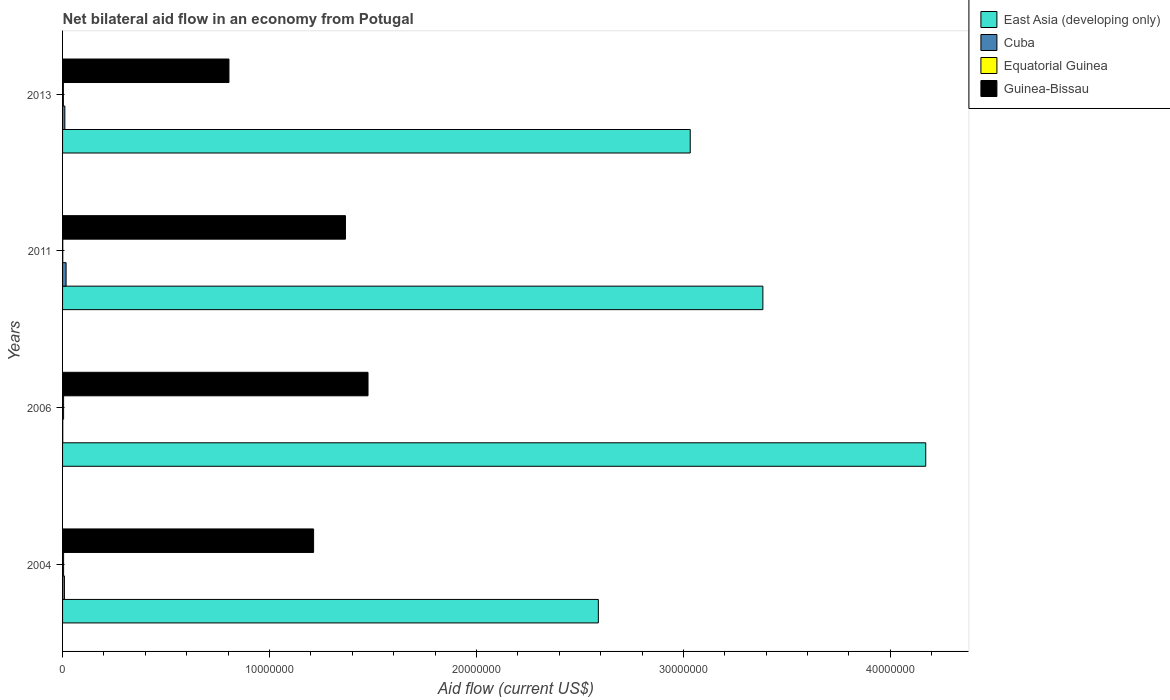How many groups of bars are there?
Offer a very short reply. 4. Are the number of bars on each tick of the Y-axis equal?
Give a very brief answer. Yes. How many bars are there on the 3rd tick from the top?
Your answer should be compact. 4. How many bars are there on the 4th tick from the bottom?
Your response must be concise. 4. What is the label of the 2nd group of bars from the top?
Keep it short and to the point. 2011. In how many cases, is the number of bars for a given year not equal to the number of legend labels?
Your answer should be very brief. 0. What is the net bilateral aid flow in Guinea-Bissau in 2013?
Provide a short and direct response. 8.04e+06. Across all years, what is the maximum net bilateral aid flow in Equatorial Guinea?
Provide a succinct answer. 5.00e+04. Across all years, what is the minimum net bilateral aid flow in Guinea-Bissau?
Your answer should be compact. 8.04e+06. In which year was the net bilateral aid flow in East Asia (developing only) maximum?
Provide a succinct answer. 2006. In which year was the net bilateral aid flow in Cuba minimum?
Give a very brief answer. 2006. What is the total net bilateral aid flow in Guinea-Bissau in the graph?
Make the answer very short. 4.86e+07. What is the difference between the net bilateral aid flow in Cuba in 2011 and that in 2013?
Provide a succinct answer. 6.00e+04. What is the difference between the net bilateral aid flow in Cuba in 2004 and the net bilateral aid flow in Equatorial Guinea in 2013?
Provide a short and direct response. 5.00e+04. What is the average net bilateral aid flow in Guinea-Bissau per year?
Offer a terse response. 1.22e+07. In the year 2006, what is the difference between the net bilateral aid flow in Cuba and net bilateral aid flow in Guinea-Bissau?
Give a very brief answer. -1.48e+07. In how many years, is the net bilateral aid flow in Guinea-Bissau greater than 8000000 US$?
Make the answer very short. 4. What is the ratio of the net bilateral aid flow in Cuba in 2006 to that in 2011?
Your answer should be compact. 0.06. Is the net bilateral aid flow in Cuba in 2004 less than that in 2011?
Provide a succinct answer. Yes. Is the difference between the net bilateral aid flow in Cuba in 2004 and 2011 greater than the difference between the net bilateral aid flow in Guinea-Bissau in 2004 and 2011?
Provide a short and direct response. Yes. What is the difference between the highest and the second highest net bilateral aid flow in Equatorial Guinea?
Ensure brevity in your answer.  0. What is the difference between the highest and the lowest net bilateral aid flow in Cuba?
Keep it short and to the point. 1.60e+05. In how many years, is the net bilateral aid flow in Equatorial Guinea greater than the average net bilateral aid flow in Equatorial Guinea taken over all years?
Your response must be concise. 3. Is it the case that in every year, the sum of the net bilateral aid flow in Equatorial Guinea and net bilateral aid flow in Guinea-Bissau is greater than the sum of net bilateral aid flow in Cuba and net bilateral aid flow in East Asia (developing only)?
Your answer should be compact. No. What does the 3rd bar from the top in 2006 represents?
Make the answer very short. Cuba. What does the 3rd bar from the bottom in 2013 represents?
Provide a short and direct response. Equatorial Guinea. What is the difference between two consecutive major ticks on the X-axis?
Ensure brevity in your answer.  1.00e+07. Does the graph contain grids?
Your response must be concise. No. How are the legend labels stacked?
Your answer should be compact. Vertical. What is the title of the graph?
Your answer should be compact. Net bilateral aid flow in an economy from Potugal. Does "Liechtenstein" appear as one of the legend labels in the graph?
Keep it short and to the point. No. What is the label or title of the X-axis?
Your answer should be compact. Aid flow (current US$). What is the label or title of the Y-axis?
Make the answer very short. Years. What is the Aid flow (current US$) of East Asia (developing only) in 2004?
Provide a succinct answer. 2.59e+07. What is the Aid flow (current US$) of Cuba in 2004?
Offer a terse response. 9.00e+04. What is the Aid flow (current US$) of Guinea-Bissau in 2004?
Your answer should be compact. 1.21e+07. What is the Aid flow (current US$) in East Asia (developing only) in 2006?
Provide a succinct answer. 4.17e+07. What is the Aid flow (current US$) in Cuba in 2006?
Make the answer very short. 10000. What is the Aid flow (current US$) of Guinea-Bissau in 2006?
Your answer should be very brief. 1.48e+07. What is the Aid flow (current US$) in East Asia (developing only) in 2011?
Make the answer very short. 3.38e+07. What is the Aid flow (current US$) of Equatorial Guinea in 2011?
Make the answer very short. 10000. What is the Aid flow (current US$) of Guinea-Bissau in 2011?
Ensure brevity in your answer.  1.37e+07. What is the Aid flow (current US$) of East Asia (developing only) in 2013?
Offer a terse response. 3.03e+07. What is the Aid flow (current US$) of Cuba in 2013?
Your response must be concise. 1.10e+05. What is the Aid flow (current US$) in Guinea-Bissau in 2013?
Provide a short and direct response. 8.04e+06. Across all years, what is the maximum Aid flow (current US$) of East Asia (developing only)?
Make the answer very short. 4.17e+07. Across all years, what is the maximum Aid flow (current US$) of Equatorial Guinea?
Your response must be concise. 5.00e+04. Across all years, what is the maximum Aid flow (current US$) of Guinea-Bissau?
Provide a short and direct response. 1.48e+07. Across all years, what is the minimum Aid flow (current US$) of East Asia (developing only)?
Provide a short and direct response. 2.59e+07. Across all years, what is the minimum Aid flow (current US$) of Equatorial Guinea?
Provide a short and direct response. 10000. Across all years, what is the minimum Aid flow (current US$) of Guinea-Bissau?
Your response must be concise. 8.04e+06. What is the total Aid flow (current US$) in East Asia (developing only) in the graph?
Make the answer very short. 1.32e+08. What is the total Aid flow (current US$) in Cuba in the graph?
Offer a very short reply. 3.80e+05. What is the total Aid flow (current US$) of Guinea-Bissau in the graph?
Keep it short and to the point. 4.86e+07. What is the difference between the Aid flow (current US$) in East Asia (developing only) in 2004 and that in 2006?
Give a very brief answer. -1.58e+07. What is the difference between the Aid flow (current US$) of Equatorial Guinea in 2004 and that in 2006?
Give a very brief answer. 0. What is the difference between the Aid flow (current US$) in Guinea-Bissau in 2004 and that in 2006?
Offer a very short reply. -2.63e+06. What is the difference between the Aid flow (current US$) of East Asia (developing only) in 2004 and that in 2011?
Give a very brief answer. -7.95e+06. What is the difference between the Aid flow (current US$) in Cuba in 2004 and that in 2011?
Give a very brief answer. -8.00e+04. What is the difference between the Aid flow (current US$) in Guinea-Bissau in 2004 and that in 2011?
Offer a very short reply. -1.54e+06. What is the difference between the Aid flow (current US$) in East Asia (developing only) in 2004 and that in 2013?
Ensure brevity in your answer.  -4.44e+06. What is the difference between the Aid flow (current US$) of Equatorial Guinea in 2004 and that in 2013?
Make the answer very short. 10000. What is the difference between the Aid flow (current US$) in Guinea-Bissau in 2004 and that in 2013?
Offer a very short reply. 4.09e+06. What is the difference between the Aid flow (current US$) of East Asia (developing only) in 2006 and that in 2011?
Provide a short and direct response. 7.87e+06. What is the difference between the Aid flow (current US$) in Equatorial Guinea in 2006 and that in 2011?
Make the answer very short. 4.00e+04. What is the difference between the Aid flow (current US$) in Guinea-Bissau in 2006 and that in 2011?
Ensure brevity in your answer.  1.09e+06. What is the difference between the Aid flow (current US$) of East Asia (developing only) in 2006 and that in 2013?
Give a very brief answer. 1.14e+07. What is the difference between the Aid flow (current US$) in Equatorial Guinea in 2006 and that in 2013?
Provide a succinct answer. 10000. What is the difference between the Aid flow (current US$) in Guinea-Bissau in 2006 and that in 2013?
Provide a succinct answer. 6.72e+06. What is the difference between the Aid flow (current US$) in East Asia (developing only) in 2011 and that in 2013?
Provide a short and direct response. 3.51e+06. What is the difference between the Aid flow (current US$) of Cuba in 2011 and that in 2013?
Your answer should be very brief. 6.00e+04. What is the difference between the Aid flow (current US$) in Equatorial Guinea in 2011 and that in 2013?
Offer a terse response. -3.00e+04. What is the difference between the Aid flow (current US$) in Guinea-Bissau in 2011 and that in 2013?
Keep it short and to the point. 5.63e+06. What is the difference between the Aid flow (current US$) of East Asia (developing only) in 2004 and the Aid flow (current US$) of Cuba in 2006?
Your answer should be compact. 2.59e+07. What is the difference between the Aid flow (current US$) of East Asia (developing only) in 2004 and the Aid flow (current US$) of Equatorial Guinea in 2006?
Provide a succinct answer. 2.58e+07. What is the difference between the Aid flow (current US$) in East Asia (developing only) in 2004 and the Aid flow (current US$) in Guinea-Bissau in 2006?
Your answer should be very brief. 1.11e+07. What is the difference between the Aid flow (current US$) of Cuba in 2004 and the Aid flow (current US$) of Equatorial Guinea in 2006?
Ensure brevity in your answer.  4.00e+04. What is the difference between the Aid flow (current US$) in Cuba in 2004 and the Aid flow (current US$) in Guinea-Bissau in 2006?
Your response must be concise. -1.47e+07. What is the difference between the Aid flow (current US$) of Equatorial Guinea in 2004 and the Aid flow (current US$) of Guinea-Bissau in 2006?
Ensure brevity in your answer.  -1.47e+07. What is the difference between the Aid flow (current US$) of East Asia (developing only) in 2004 and the Aid flow (current US$) of Cuba in 2011?
Offer a terse response. 2.57e+07. What is the difference between the Aid flow (current US$) in East Asia (developing only) in 2004 and the Aid flow (current US$) in Equatorial Guinea in 2011?
Your answer should be very brief. 2.59e+07. What is the difference between the Aid flow (current US$) in East Asia (developing only) in 2004 and the Aid flow (current US$) in Guinea-Bissau in 2011?
Provide a short and direct response. 1.22e+07. What is the difference between the Aid flow (current US$) of Cuba in 2004 and the Aid flow (current US$) of Equatorial Guinea in 2011?
Provide a short and direct response. 8.00e+04. What is the difference between the Aid flow (current US$) of Cuba in 2004 and the Aid flow (current US$) of Guinea-Bissau in 2011?
Your response must be concise. -1.36e+07. What is the difference between the Aid flow (current US$) of Equatorial Guinea in 2004 and the Aid flow (current US$) of Guinea-Bissau in 2011?
Make the answer very short. -1.36e+07. What is the difference between the Aid flow (current US$) in East Asia (developing only) in 2004 and the Aid flow (current US$) in Cuba in 2013?
Give a very brief answer. 2.58e+07. What is the difference between the Aid flow (current US$) in East Asia (developing only) in 2004 and the Aid flow (current US$) in Equatorial Guinea in 2013?
Offer a very short reply. 2.58e+07. What is the difference between the Aid flow (current US$) of East Asia (developing only) in 2004 and the Aid flow (current US$) of Guinea-Bissau in 2013?
Provide a short and direct response. 1.78e+07. What is the difference between the Aid flow (current US$) in Cuba in 2004 and the Aid flow (current US$) in Guinea-Bissau in 2013?
Offer a very short reply. -7.95e+06. What is the difference between the Aid flow (current US$) in Equatorial Guinea in 2004 and the Aid flow (current US$) in Guinea-Bissau in 2013?
Offer a very short reply. -7.99e+06. What is the difference between the Aid flow (current US$) in East Asia (developing only) in 2006 and the Aid flow (current US$) in Cuba in 2011?
Make the answer very short. 4.15e+07. What is the difference between the Aid flow (current US$) of East Asia (developing only) in 2006 and the Aid flow (current US$) of Equatorial Guinea in 2011?
Your answer should be compact. 4.17e+07. What is the difference between the Aid flow (current US$) of East Asia (developing only) in 2006 and the Aid flow (current US$) of Guinea-Bissau in 2011?
Ensure brevity in your answer.  2.80e+07. What is the difference between the Aid flow (current US$) of Cuba in 2006 and the Aid flow (current US$) of Guinea-Bissau in 2011?
Keep it short and to the point. -1.37e+07. What is the difference between the Aid flow (current US$) of Equatorial Guinea in 2006 and the Aid flow (current US$) of Guinea-Bissau in 2011?
Your response must be concise. -1.36e+07. What is the difference between the Aid flow (current US$) of East Asia (developing only) in 2006 and the Aid flow (current US$) of Cuba in 2013?
Ensure brevity in your answer.  4.16e+07. What is the difference between the Aid flow (current US$) of East Asia (developing only) in 2006 and the Aid flow (current US$) of Equatorial Guinea in 2013?
Your answer should be compact. 4.17e+07. What is the difference between the Aid flow (current US$) in East Asia (developing only) in 2006 and the Aid flow (current US$) in Guinea-Bissau in 2013?
Make the answer very short. 3.37e+07. What is the difference between the Aid flow (current US$) of Cuba in 2006 and the Aid flow (current US$) of Equatorial Guinea in 2013?
Your answer should be very brief. -3.00e+04. What is the difference between the Aid flow (current US$) in Cuba in 2006 and the Aid flow (current US$) in Guinea-Bissau in 2013?
Keep it short and to the point. -8.03e+06. What is the difference between the Aid flow (current US$) of Equatorial Guinea in 2006 and the Aid flow (current US$) of Guinea-Bissau in 2013?
Ensure brevity in your answer.  -7.99e+06. What is the difference between the Aid flow (current US$) of East Asia (developing only) in 2011 and the Aid flow (current US$) of Cuba in 2013?
Offer a terse response. 3.37e+07. What is the difference between the Aid flow (current US$) in East Asia (developing only) in 2011 and the Aid flow (current US$) in Equatorial Guinea in 2013?
Provide a succinct answer. 3.38e+07. What is the difference between the Aid flow (current US$) of East Asia (developing only) in 2011 and the Aid flow (current US$) of Guinea-Bissau in 2013?
Ensure brevity in your answer.  2.58e+07. What is the difference between the Aid flow (current US$) of Cuba in 2011 and the Aid flow (current US$) of Guinea-Bissau in 2013?
Offer a terse response. -7.87e+06. What is the difference between the Aid flow (current US$) in Equatorial Guinea in 2011 and the Aid flow (current US$) in Guinea-Bissau in 2013?
Offer a terse response. -8.03e+06. What is the average Aid flow (current US$) in East Asia (developing only) per year?
Your answer should be compact. 3.29e+07. What is the average Aid flow (current US$) of Cuba per year?
Your response must be concise. 9.50e+04. What is the average Aid flow (current US$) in Equatorial Guinea per year?
Give a very brief answer. 3.75e+04. What is the average Aid flow (current US$) in Guinea-Bissau per year?
Provide a short and direct response. 1.22e+07. In the year 2004, what is the difference between the Aid flow (current US$) in East Asia (developing only) and Aid flow (current US$) in Cuba?
Ensure brevity in your answer.  2.58e+07. In the year 2004, what is the difference between the Aid flow (current US$) of East Asia (developing only) and Aid flow (current US$) of Equatorial Guinea?
Keep it short and to the point. 2.58e+07. In the year 2004, what is the difference between the Aid flow (current US$) in East Asia (developing only) and Aid flow (current US$) in Guinea-Bissau?
Your response must be concise. 1.38e+07. In the year 2004, what is the difference between the Aid flow (current US$) in Cuba and Aid flow (current US$) in Equatorial Guinea?
Offer a very short reply. 4.00e+04. In the year 2004, what is the difference between the Aid flow (current US$) of Cuba and Aid flow (current US$) of Guinea-Bissau?
Your answer should be compact. -1.20e+07. In the year 2004, what is the difference between the Aid flow (current US$) in Equatorial Guinea and Aid flow (current US$) in Guinea-Bissau?
Your answer should be very brief. -1.21e+07. In the year 2006, what is the difference between the Aid flow (current US$) of East Asia (developing only) and Aid flow (current US$) of Cuba?
Your response must be concise. 4.17e+07. In the year 2006, what is the difference between the Aid flow (current US$) of East Asia (developing only) and Aid flow (current US$) of Equatorial Guinea?
Provide a short and direct response. 4.17e+07. In the year 2006, what is the difference between the Aid flow (current US$) of East Asia (developing only) and Aid flow (current US$) of Guinea-Bissau?
Ensure brevity in your answer.  2.70e+07. In the year 2006, what is the difference between the Aid flow (current US$) of Cuba and Aid flow (current US$) of Guinea-Bissau?
Your answer should be compact. -1.48e+07. In the year 2006, what is the difference between the Aid flow (current US$) of Equatorial Guinea and Aid flow (current US$) of Guinea-Bissau?
Provide a succinct answer. -1.47e+07. In the year 2011, what is the difference between the Aid flow (current US$) in East Asia (developing only) and Aid flow (current US$) in Cuba?
Make the answer very short. 3.37e+07. In the year 2011, what is the difference between the Aid flow (current US$) in East Asia (developing only) and Aid flow (current US$) in Equatorial Guinea?
Offer a very short reply. 3.38e+07. In the year 2011, what is the difference between the Aid flow (current US$) in East Asia (developing only) and Aid flow (current US$) in Guinea-Bissau?
Keep it short and to the point. 2.02e+07. In the year 2011, what is the difference between the Aid flow (current US$) of Cuba and Aid flow (current US$) of Guinea-Bissau?
Your answer should be very brief. -1.35e+07. In the year 2011, what is the difference between the Aid flow (current US$) in Equatorial Guinea and Aid flow (current US$) in Guinea-Bissau?
Keep it short and to the point. -1.37e+07. In the year 2013, what is the difference between the Aid flow (current US$) of East Asia (developing only) and Aid flow (current US$) of Cuba?
Your response must be concise. 3.02e+07. In the year 2013, what is the difference between the Aid flow (current US$) in East Asia (developing only) and Aid flow (current US$) in Equatorial Guinea?
Your answer should be very brief. 3.03e+07. In the year 2013, what is the difference between the Aid flow (current US$) in East Asia (developing only) and Aid flow (current US$) in Guinea-Bissau?
Your answer should be compact. 2.23e+07. In the year 2013, what is the difference between the Aid flow (current US$) in Cuba and Aid flow (current US$) in Equatorial Guinea?
Keep it short and to the point. 7.00e+04. In the year 2013, what is the difference between the Aid flow (current US$) in Cuba and Aid flow (current US$) in Guinea-Bissau?
Your answer should be compact. -7.93e+06. In the year 2013, what is the difference between the Aid flow (current US$) of Equatorial Guinea and Aid flow (current US$) of Guinea-Bissau?
Give a very brief answer. -8.00e+06. What is the ratio of the Aid flow (current US$) of East Asia (developing only) in 2004 to that in 2006?
Give a very brief answer. 0.62. What is the ratio of the Aid flow (current US$) of Cuba in 2004 to that in 2006?
Provide a succinct answer. 9. What is the ratio of the Aid flow (current US$) of Guinea-Bissau in 2004 to that in 2006?
Your answer should be compact. 0.82. What is the ratio of the Aid flow (current US$) of East Asia (developing only) in 2004 to that in 2011?
Provide a short and direct response. 0.77. What is the ratio of the Aid flow (current US$) in Cuba in 2004 to that in 2011?
Your answer should be compact. 0.53. What is the ratio of the Aid flow (current US$) in Guinea-Bissau in 2004 to that in 2011?
Offer a terse response. 0.89. What is the ratio of the Aid flow (current US$) of East Asia (developing only) in 2004 to that in 2013?
Ensure brevity in your answer.  0.85. What is the ratio of the Aid flow (current US$) in Cuba in 2004 to that in 2013?
Offer a very short reply. 0.82. What is the ratio of the Aid flow (current US$) in Guinea-Bissau in 2004 to that in 2013?
Provide a short and direct response. 1.51. What is the ratio of the Aid flow (current US$) of East Asia (developing only) in 2006 to that in 2011?
Offer a terse response. 1.23. What is the ratio of the Aid flow (current US$) in Cuba in 2006 to that in 2011?
Your answer should be very brief. 0.06. What is the ratio of the Aid flow (current US$) of Guinea-Bissau in 2006 to that in 2011?
Ensure brevity in your answer.  1.08. What is the ratio of the Aid flow (current US$) of East Asia (developing only) in 2006 to that in 2013?
Keep it short and to the point. 1.38. What is the ratio of the Aid flow (current US$) of Cuba in 2006 to that in 2013?
Offer a terse response. 0.09. What is the ratio of the Aid flow (current US$) in Guinea-Bissau in 2006 to that in 2013?
Give a very brief answer. 1.84. What is the ratio of the Aid flow (current US$) of East Asia (developing only) in 2011 to that in 2013?
Keep it short and to the point. 1.12. What is the ratio of the Aid flow (current US$) of Cuba in 2011 to that in 2013?
Provide a short and direct response. 1.55. What is the ratio of the Aid flow (current US$) in Equatorial Guinea in 2011 to that in 2013?
Your answer should be very brief. 0.25. What is the ratio of the Aid flow (current US$) in Guinea-Bissau in 2011 to that in 2013?
Offer a terse response. 1.7. What is the difference between the highest and the second highest Aid flow (current US$) of East Asia (developing only)?
Provide a short and direct response. 7.87e+06. What is the difference between the highest and the second highest Aid flow (current US$) of Equatorial Guinea?
Your response must be concise. 0. What is the difference between the highest and the second highest Aid flow (current US$) in Guinea-Bissau?
Ensure brevity in your answer.  1.09e+06. What is the difference between the highest and the lowest Aid flow (current US$) in East Asia (developing only)?
Provide a succinct answer. 1.58e+07. What is the difference between the highest and the lowest Aid flow (current US$) of Cuba?
Offer a very short reply. 1.60e+05. What is the difference between the highest and the lowest Aid flow (current US$) of Guinea-Bissau?
Give a very brief answer. 6.72e+06. 